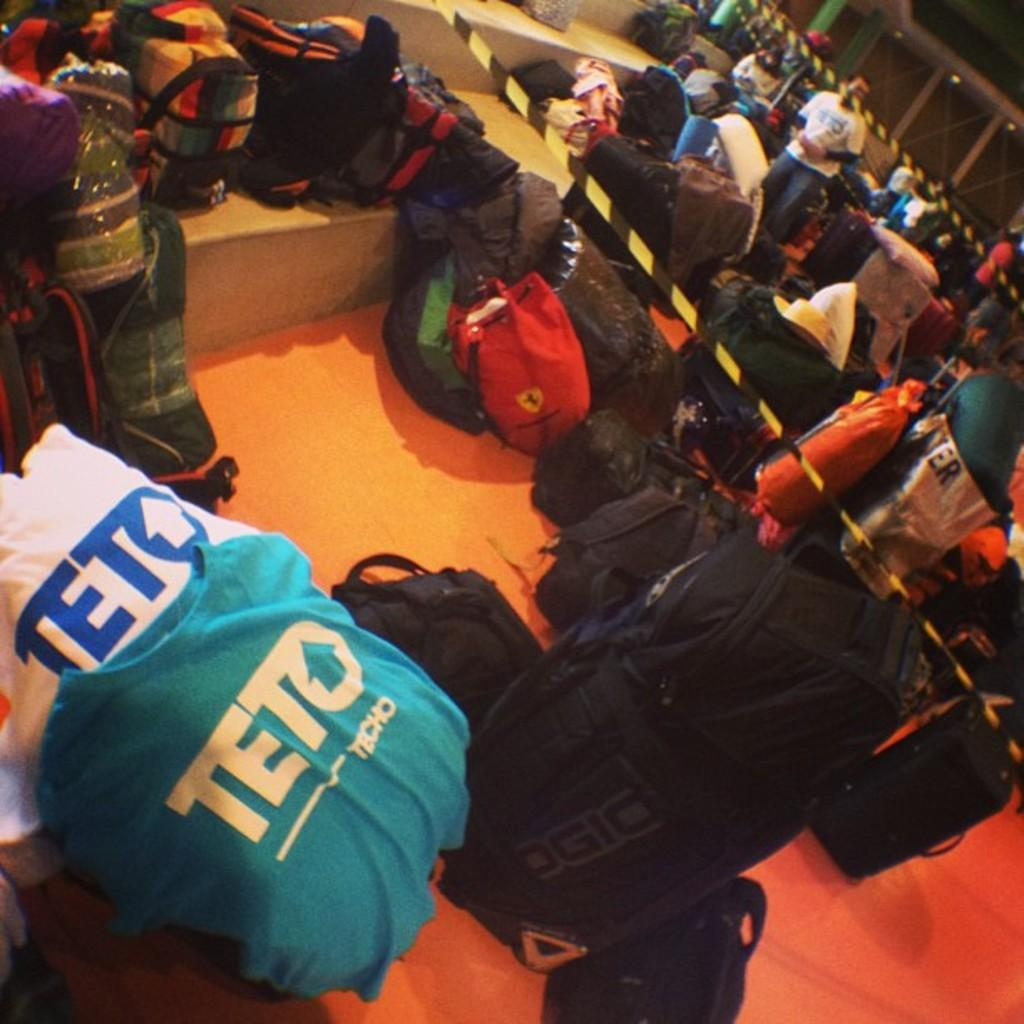<image>
Share a concise interpretation of the image provided. Luggages and some shirts with one saying TETO on the chest. 